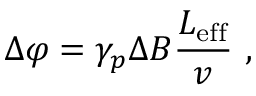Convert formula to latex. <formula><loc_0><loc_0><loc_500><loc_500>\Delta \varphi = \gamma _ { p } \Delta B \frac { L _ { e f f } } { v } \ ,</formula> 